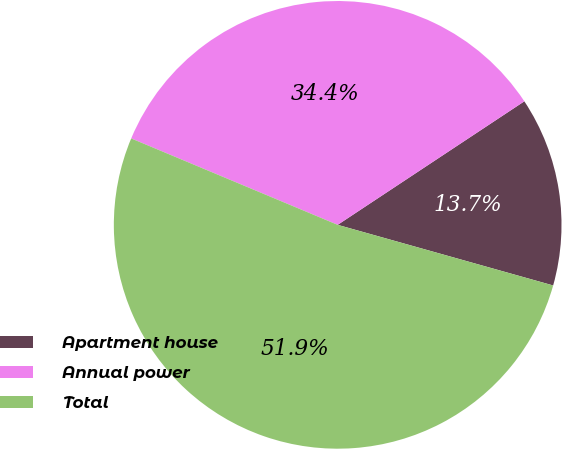<chart> <loc_0><loc_0><loc_500><loc_500><pie_chart><fcel>Apartment house<fcel>Annual power<fcel>Total<nl><fcel>13.67%<fcel>34.39%<fcel>51.95%<nl></chart> 